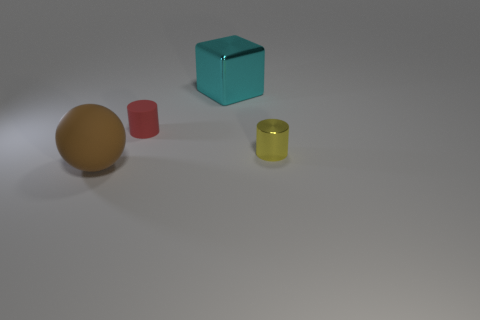What feelings or concepts could this arrangement of objects represent? This arrangement of objects could represent concepts of balance, order, and simplicity. The clean lines, uncluttered background, and limited color palette evoke a sense of calm and minimalism. It could also be seen as a metaphor for diversity and unity, with various shapes and sizes co-existing harmoniously in the same space. 